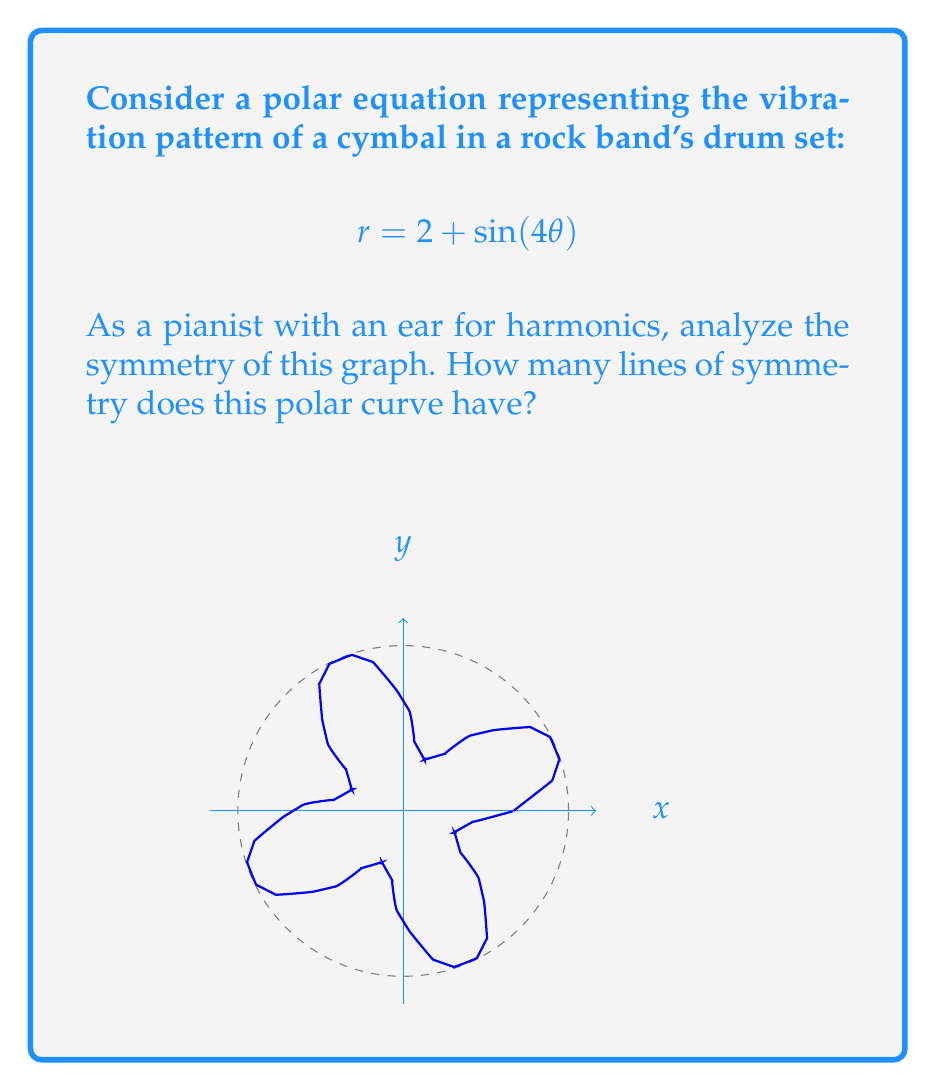What is the answer to this math problem? Let's approach this step-by-step:

1) First, recall that for a polar curve $r = f(\theta)$, we have symmetry about the x-axis if $f(\theta) = f(-\theta)$ for all $\theta$.

2) In our case, $f(\theta) = 2 + \sin(4\theta)$. Let's check if $f(-\theta) = f(\theta)$:
   
   $f(-\theta) = 2 + \sin(-4\theta) = 2 - \sin(4\theta)$

   This is not equal to $f(\theta)$, so there's no symmetry about the x-axis.

3) For symmetry about the y-axis, we need $f(\theta) = f(\pi - \theta)$ for all $\theta$. Let's check:
   
   $f(\pi - \theta) = 2 + \sin(4(\pi - \theta)) = 2 + \sin(4\pi - 4\theta) = 2 + \sin(-4\theta) = 2 - \sin(4\theta)$

   This is not equal to $f(\theta)$, so there's no symmetry about the y-axis.

4) For symmetry about the origin, we need $f(\theta) = f(\theta + \pi)$ for all $\theta$. Let's check:
   
   $f(\theta + \pi) = 2 + \sin(4(\theta + \pi)) = 2 + \sin(4\theta + 4\pi) = 2 + \sin(4\theta)$

   This is equal to $f(\theta)$, so we have symmetry about the origin.

5) To find all lines of symmetry, we need to check for symmetry about lines $\theta = \frac{\pi}{n}$ where $n$ is a positive integer.

6) The curve repeats every $\frac{\pi}{2}$ due to the $\sin(4\theta)$ term. This means we need to check $\theta = 0, \frac{\pi}{4}, \frac{\pi}{2}, \frac{3\pi}{4}$.

7) We've already checked $\theta = 0$ and $\frac{\pi}{2}$ (x and y axes). Let's check $\frac{\pi}{4}$ and $\frac{3\pi}{4}$:

   For $\theta = \frac{\pi}{4}$: $f(\frac{\pi}{4} - \theta) = 2 + \sin(\pi - 4\theta) = 2 - \sin(4\theta) = f(\frac{\pi}{4} + \theta)$
   For $\theta = \frac{3\pi}{4}$: $f(\frac{3\pi}{4} - \theta) = 2 + \sin(3\pi - 4\theta) = 2 - \sin(4\theta) = f(\frac{3\pi}{4} + \theta)$

8) Therefore, we have symmetry about the lines $\theta = \frac{\pi}{4}$ and $\theta = \frac{3\pi}{4}$.

In total, we have 4 lines of symmetry: the two diagonals ($\theta = \frac{\pi}{4}$ and $\theta = \frac{3\pi}{4}$), and the two lines through the origin perpendicular to these diagonals.
Answer: 4 lines of symmetry 